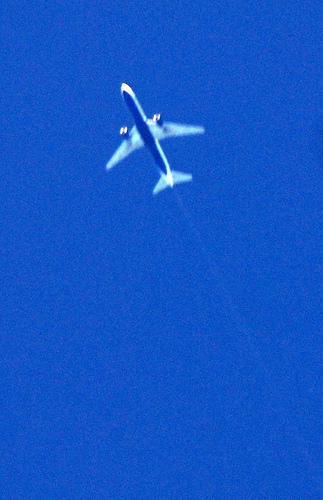How many propellers are visible in this picture?
Give a very brief answer. 0. 